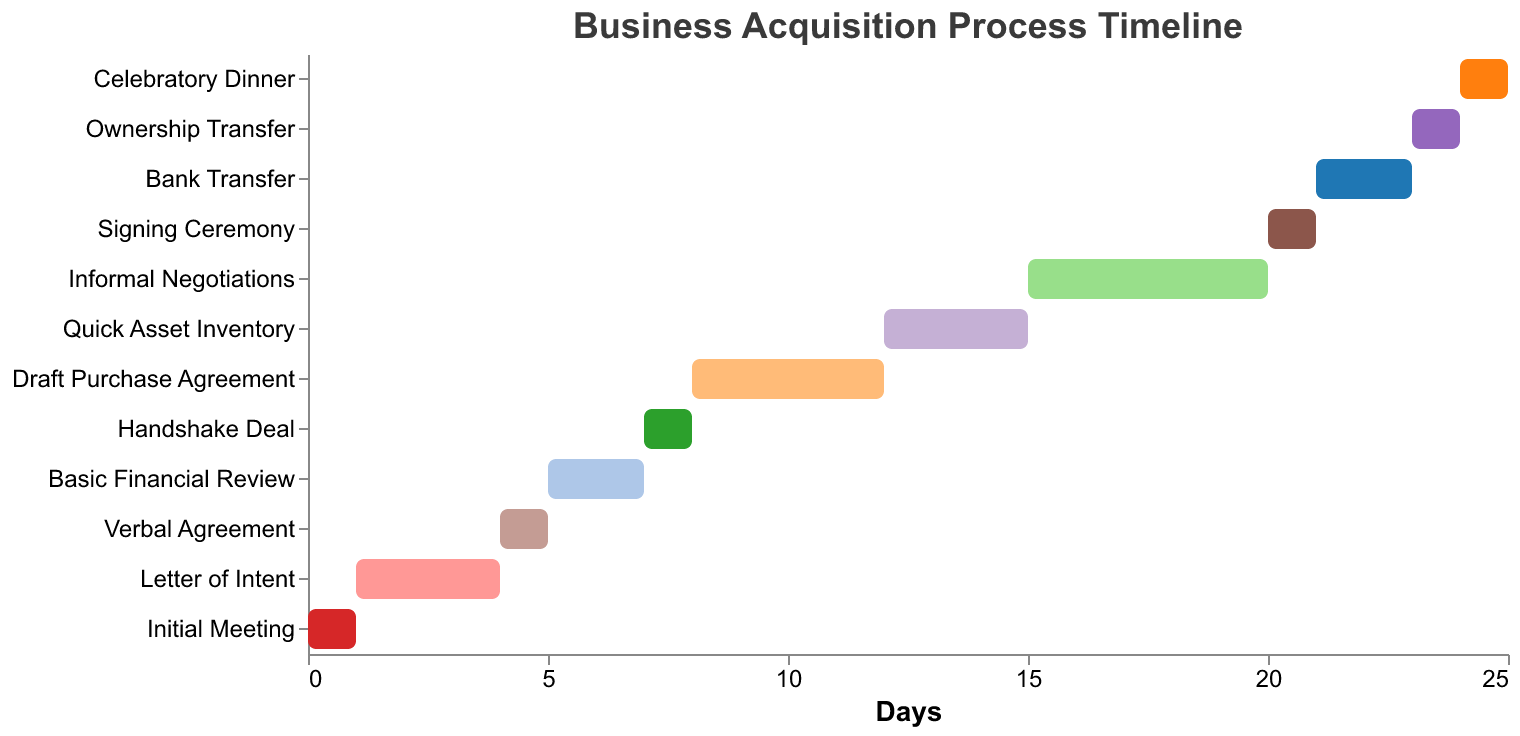What is the total duration of the 'Informal Negotiations' task? 'Informal Negotiations' starts at day 15 and lasts for 5 days. Therefore, its duration is 5 days.
Answer: 5 days What task has the shortest duration? To find the task with the shortest duration, we need to compare the durations of all tasks. 'Initial Meeting', 'Verbal Agreement', 'Handshake Deal', 'Signing Ceremony', 'Ownership Transfer', and 'Celebratory Dinner' each have a duration of 1 day.
Answer: Multiple tasks (1 day each) On which day does the 'Basic Financial Review' end? The 'Basic Financial Review' starts on day 5 and lasts for 2 days, so it ends on day 7.
Answer: Day 7 Which task takes place immediately before the 'Quick Asset Inventory'? 'Quick Asset Inventory' starts on day 12; the task that ends right before this is the 'Draft Purchase Agreement' which ends on day 12.
Answer: Draft Purchase Agreement How many tasks have a duration of more than 3 days? To find the tasks with a duration of more than 3 days, we count 'Letter of Intent' (3 days), 'Draft Purchase Agreement' (4 days), and 'Informal Negotiations' (5 days).
Answer: 3 tasks Which tasks start after day 20? Tasks that start after day 20 are 'Bank Transfer' (day 21), 'Ownership Transfer' (day 23), and 'Celebratory Dinner' (day 24).
Answer: 3 tasks What is the difference in days between the start of 'Initial Meeting' and 'Celebratory Dinner'? 'Initial Meeting' starts on day 0 and 'Celebratory Dinner' starts on day 24. The difference is 24 days.
Answer: 24 days Which task takes the longest duration to complete? By comparing durations, 'Informal Negotiations' takes the longest with a duration of 5 days.
Answer: Informal Negotiations When does the 'Verbal Agreement' task occur? 'Verbal Agreement' starts on day 4 and lasts for 1 day, so it occurs on day 4.
Answer: Day 4 How long in total do the first three tasks take? The first three tasks are 'Initial Meeting' (1 day), 'Letter of Intent' (3 days), and 'Verbal Agreement' (1 day). Adding these gives 1 + 3 + 1 = 5 days.
Answer: 5 days 